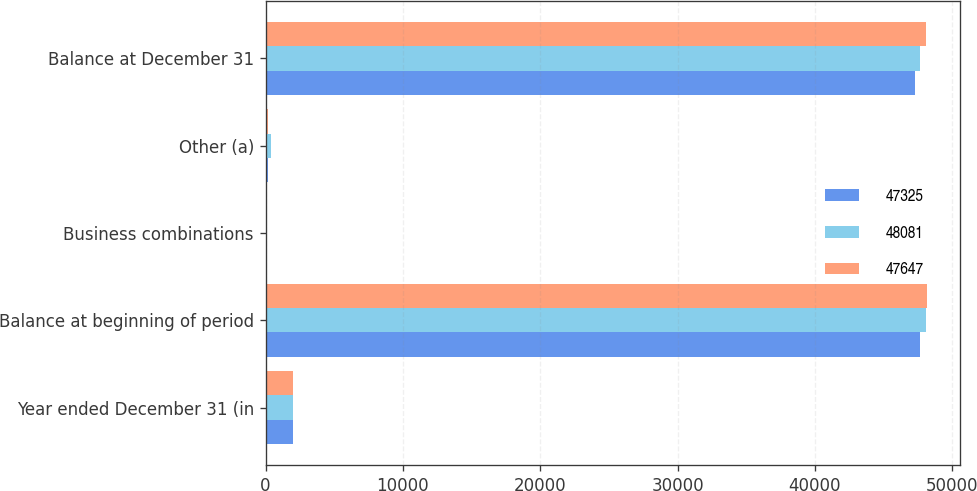<chart> <loc_0><loc_0><loc_500><loc_500><stacked_bar_chart><ecel><fcel>Year ended December 31 (in<fcel>Balance at beginning of period<fcel>Business combinations<fcel>Other (a)<fcel>Balance at December 31<nl><fcel>47325<fcel>2015<fcel>47647<fcel>28<fcel>190<fcel>47325<nl><fcel>48081<fcel>2014<fcel>48081<fcel>43<fcel>397<fcel>47647<nl><fcel>47647<fcel>2013<fcel>48175<fcel>64<fcel>153<fcel>48081<nl></chart> 